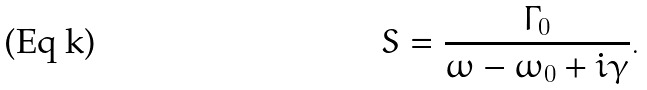<formula> <loc_0><loc_0><loc_500><loc_500>S = \frac { \Gamma _ { 0 } } { \omega - \omega _ { 0 } + i \gamma } .</formula> 